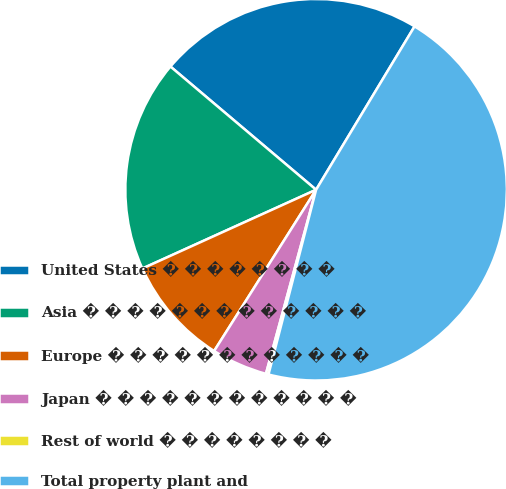Convert chart to OTSL. <chart><loc_0><loc_0><loc_500><loc_500><pie_chart><fcel>United States � � � � � � � �<fcel>Asia � � � � � � � � � � � � �<fcel>Europe � � � � � � � � � � � �<fcel>Japan � � � � � � � � � � � �<fcel>Rest of world � � � � � � � �<fcel>Total property plant and<nl><fcel>22.46%<fcel>17.95%<fcel>9.25%<fcel>4.74%<fcel>0.22%<fcel>45.38%<nl></chart> 